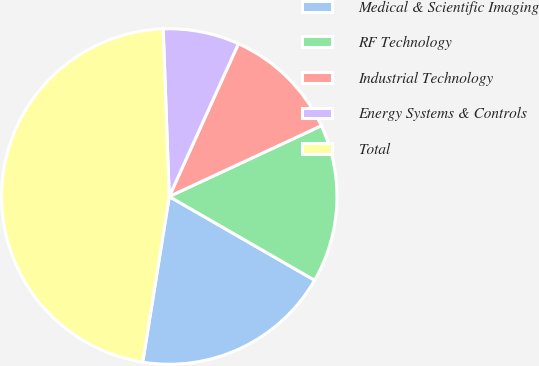Convert chart to OTSL. <chart><loc_0><loc_0><loc_500><loc_500><pie_chart><fcel>Medical & Scientific Imaging<fcel>RF Technology<fcel>Industrial Technology<fcel>Energy Systems & Controls<fcel>Total<nl><fcel>19.21%<fcel>15.25%<fcel>11.3%<fcel>7.34%<fcel>46.89%<nl></chart> 